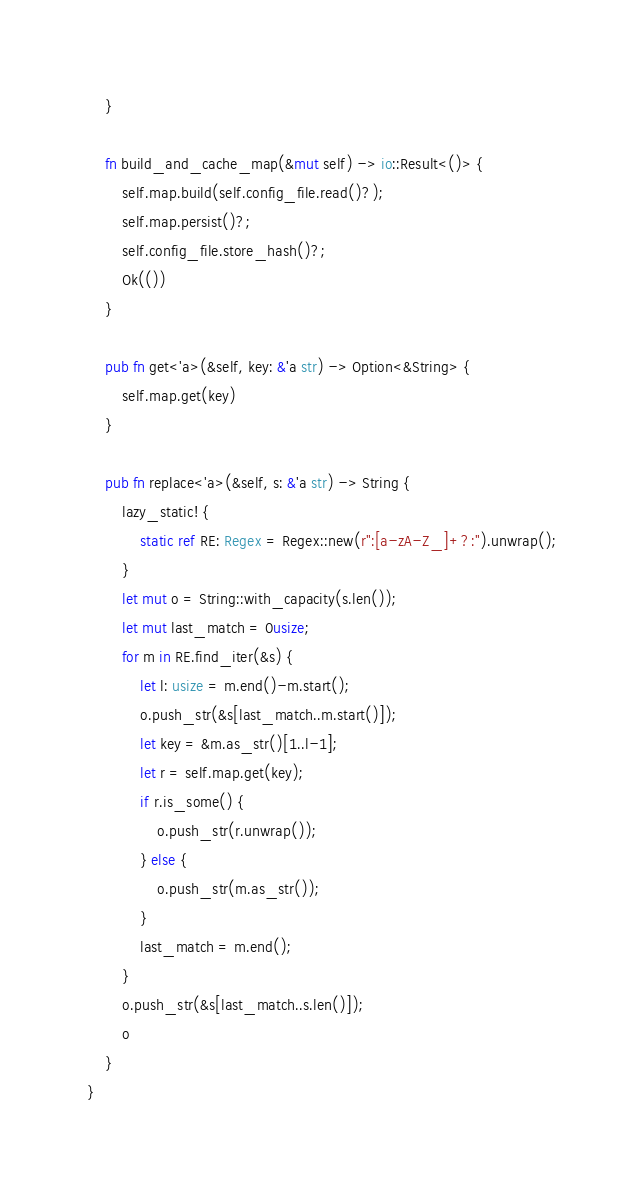Convert code to text. <code><loc_0><loc_0><loc_500><loc_500><_Rust_>    }
    
    fn build_and_cache_map(&mut self) -> io::Result<()> {
        self.map.build(self.config_file.read()?);
        self.map.persist()?;
        self.config_file.store_hash()?;
        Ok(())
    }

    pub fn get<'a>(&self, key: &'a str) -> Option<&String> {
        self.map.get(key)
    }

    pub fn replace<'a>(&self, s: &'a str) -> String {
        lazy_static! {
            static ref RE: Regex = Regex::new(r":[a-zA-Z_]+?:").unwrap();
        }
        let mut o = String::with_capacity(s.len());
        let mut last_match = 0usize;
        for m in RE.find_iter(&s) {
            let l: usize = m.end()-m.start();
            o.push_str(&s[last_match..m.start()]);
            let key = &m.as_str()[1..l-1];
            let r = self.map.get(key);
            if r.is_some() {
                o.push_str(r.unwrap());
            } else {
                o.push_str(m.as_str());
            }
            last_match = m.end();
        }
        o.push_str(&s[last_match..s.len()]);
        o
    }
}
</code> 